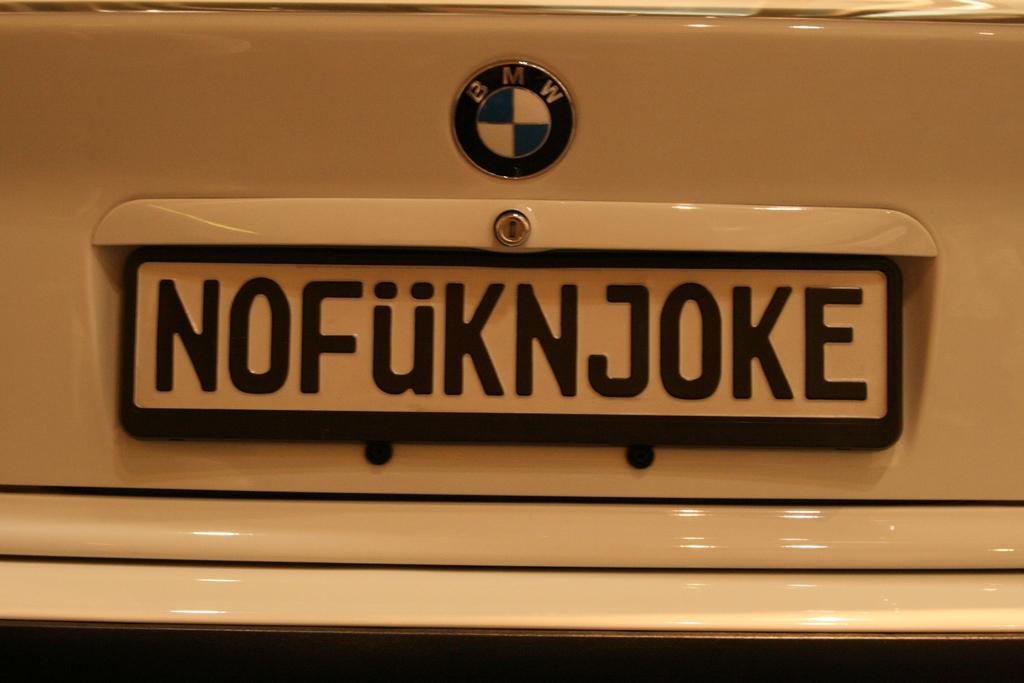What is the car brand logo shown?
Your response must be concise. Bmw. 